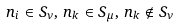<formula> <loc_0><loc_0><loc_500><loc_500>n _ { i } \in S _ { \nu } , \, n _ { k } \in S _ { \mu } , \, n _ { k } \notin S _ { \nu }</formula> 